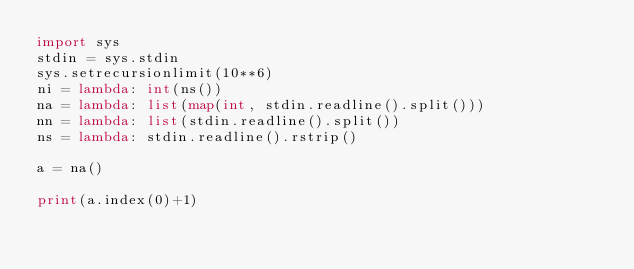<code> <loc_0><loc_0><loc_500><loc_500><_Python_>import sys
stdin = sys.stdin
sys.setrecursionlimit(10**6)
ni = lambda: int(ns())
na = lambda: list(map(int, stdin.readline().split()))
nn = lambda: list(stdin.readline().split())
ns = lambda: stdin.readline().rstrip()

a = na()

print(a.index(0)+1)</code> 